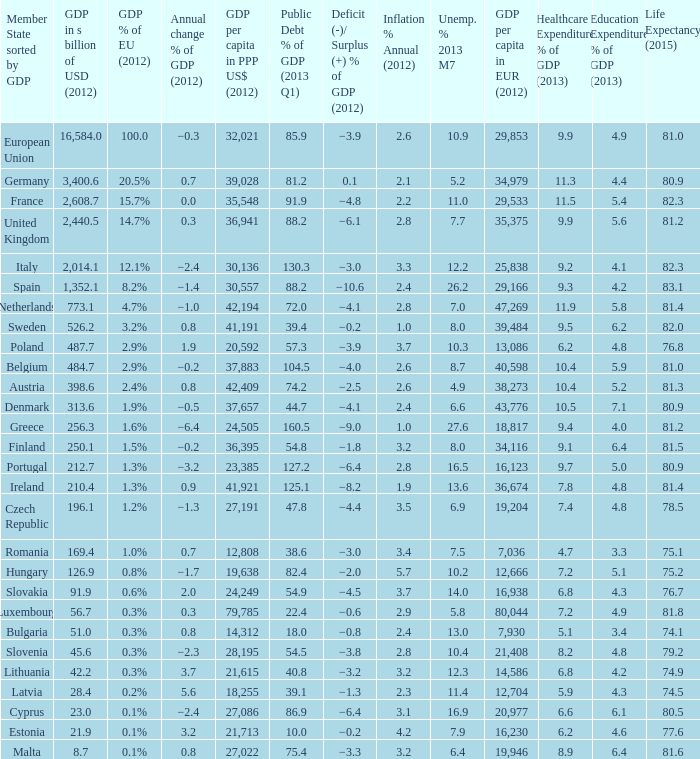What is the largest inflation % annual in 2012 of the country with a public debt % of GDP in 2013 Q1 greater than 88.2 and a GDP % of EU in 2012 of 2.9%? 2.6. 